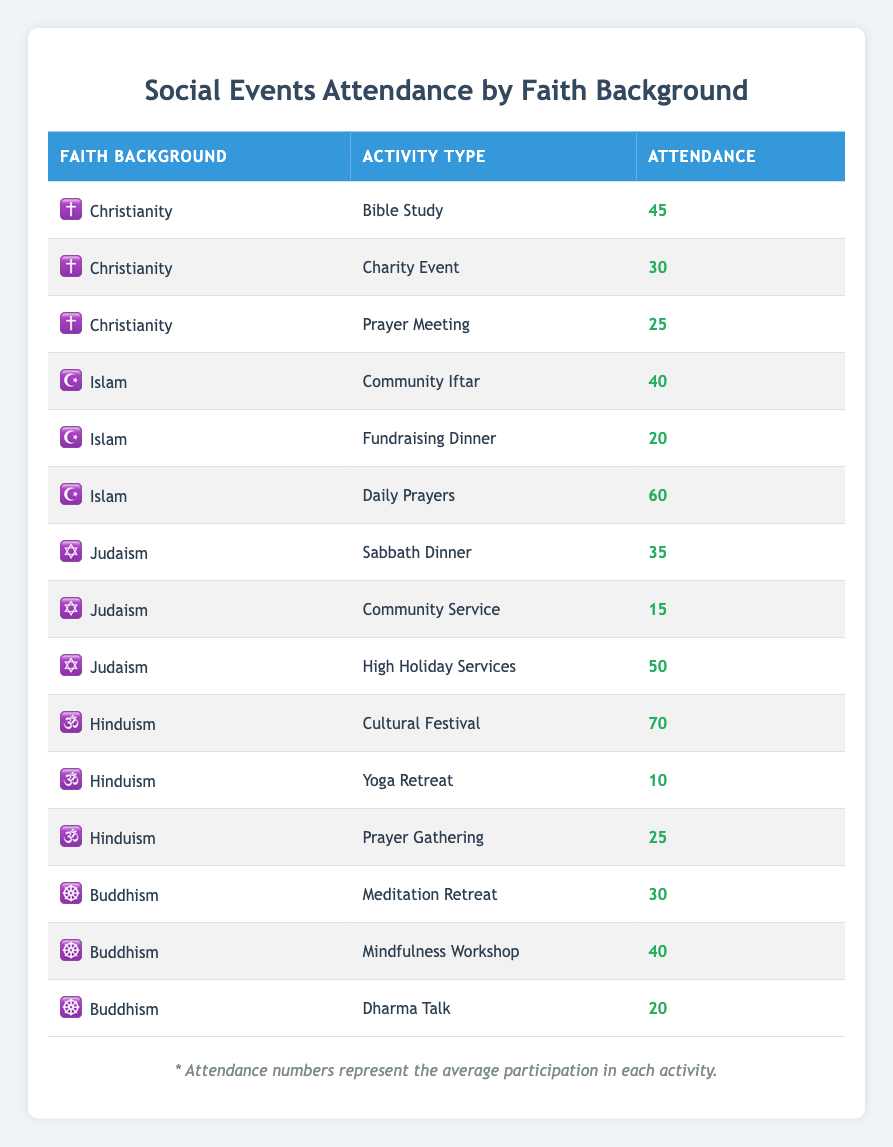What faith background had the highest attendance in Cultural Festival? The Cultural Festival attendance for Hinduism is 70, which is higher than any other faith background's activity attendance, as none of the other faith backgrounds have an activity listed that exceeds this value.
Answer: Hinduism What is the total attendance for Christianity activities? The attendance for Christianity activities includes Bible Study (45), Charity Event (30), and Prayer Meeting (25). Summing these values gives 45 + 30 + 25 = 100.
Answer: 100 Did Judaism have more attendees at High Holiday Services than Islam at Daily Prayers? The High Holiday Services for Judaism had 50 attendees, while Daily Prayers for Islam had 60 attendees. Since 50 is less than 60, the statement is false.
Answer: No Which activity type under Buddhism had the least attendance? The attendance for Buddhism activities shows Meditation Retreat (30), Mindfulness Workshop (40), and Dharma Talk (20). Dharma Talk has the lowest attendance of these three, which is 20.
Answer: Dharma Talk What is the average attendance across all activities for Hinduism? Hinduism had Cultural Festival (70), Yoga Retreat (10), and Prayer Gathering (25). First, sum these values: 70 + 10 + 25 = 105. Then, divide by the number of activities (3). Thus, the average is 105/3 = 35.
Answer: 35 Is the attendance for Charity Event higher than that for Community Service in Judaism? The Charity Event under Christianity had 30 attendees. The Community Service for Judaism had 15 attendees. Since 30 is greater than 15, the statement is true.
Answer: Yes What is the total attendance across all Islamic events? The Islamic events include Community Iftar (40), Fundraising Dinner (20), and Daily Prayers (60). Their total attendance is 40 + 20 + 60 = 120.
Answer: 120 Which faith background has the lowest total attendance for their events? For each faith background, summarize the attendance: Christianity (100), Islam (120), Judaism (100), Hinduism (105), and Buddhism (90). Buddhism has the lowest total attendance at 90, compared to the others.
Answer: Buddhism 